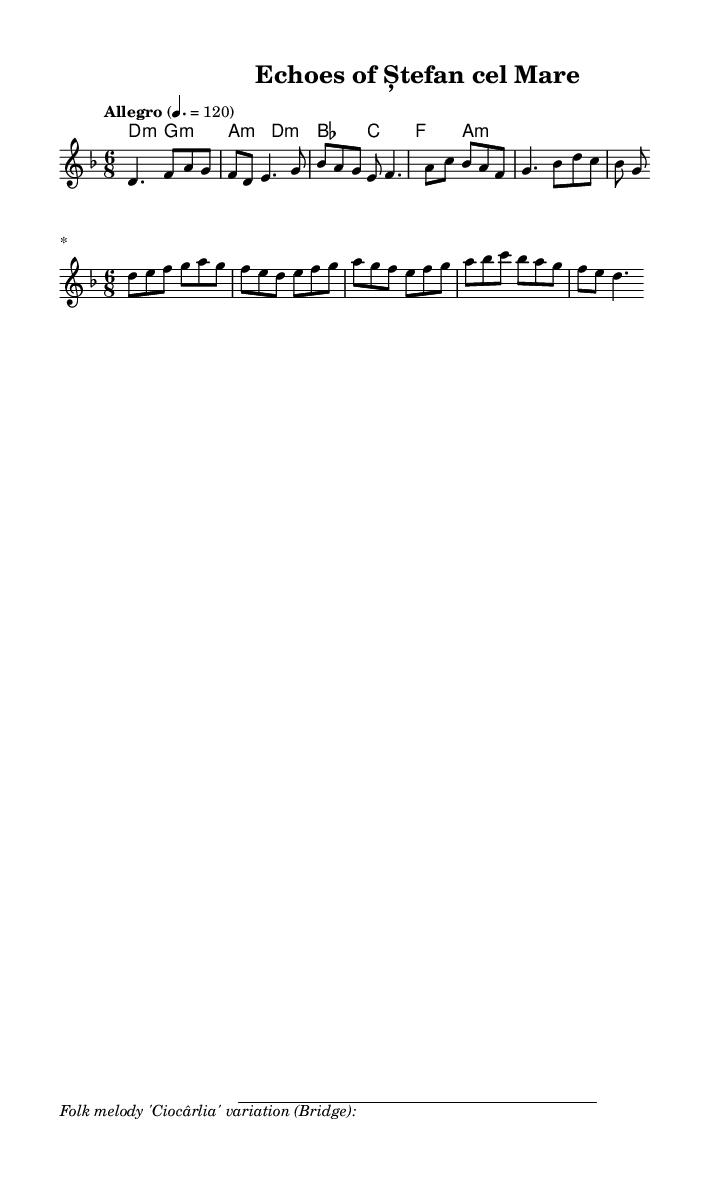What is the key signature of this music? The key signature indicated on the staff shows two flats, which corresponds to the key of D minor.
Answer: D minor What is the time signature of the piece? The time signature shown at the beginning of the score is 6/8, indicating six eighth notes per measure.
Answer: 6/8 What is the tempo marking for this composition? The tempo marking states "Allegro" with a metronome indication of 120 beats per minute, suggesting a fast-paced performance.
Answer: Allegro, 120 How many measures are in the melody section? By counting the groups of vertical lines that separate the sections of music, there are a total of 8 measures in the melody.
Answer: 8 What is the name of the folk melody variation included in the music? The footnote in the markup specifies that the variation is of the folk melody "Ciocârlia".
Answer: Ciocârlia What type of harmony is used in this piece? The harmony section presents primarily minor chords, indicating a dark, melodic texture characteristic of symphonic metal.
Answer: Minor chords In what style does this piece fuse Moldovan elements? The piece incorporates ancient Moldovan folk melodies and historical themes, blending them into a symphonic metal context.
Answer: Symphonic metal with folk elements 